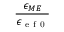<formula> <loc_0><loc_0><loc_500><loc_500>\frac { \epsilon _ { M E } } { \epsilon _ { e f 0 } }</formula> 